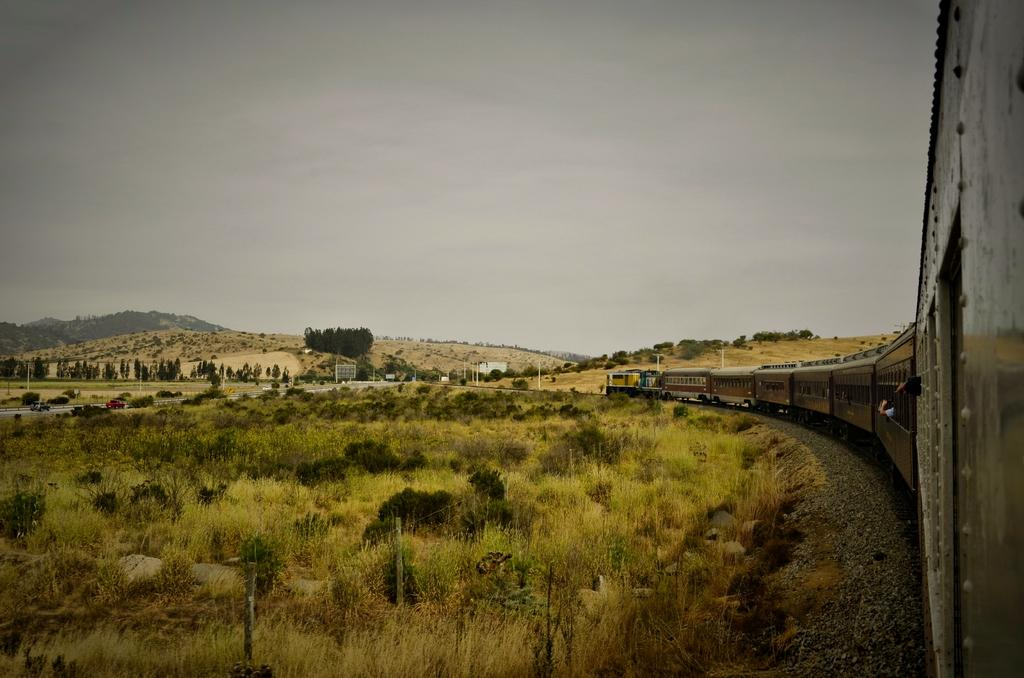What is the main subject of the image? The main subject of the image is a train. Where is the train located in the image? The train is on a railway track. What type of natural features can be seen in the image? There are trees and mountains in the image. What is the purpose of the fence in the image? The fence is likely used to separate the railway track from the surrounding area. What is visible in the background of the image? The sky is visible in the background of the image. Where is the desk located in the image? There is no desk present in the image; it features a train on a railway track with trees, mountains, and a fence. 